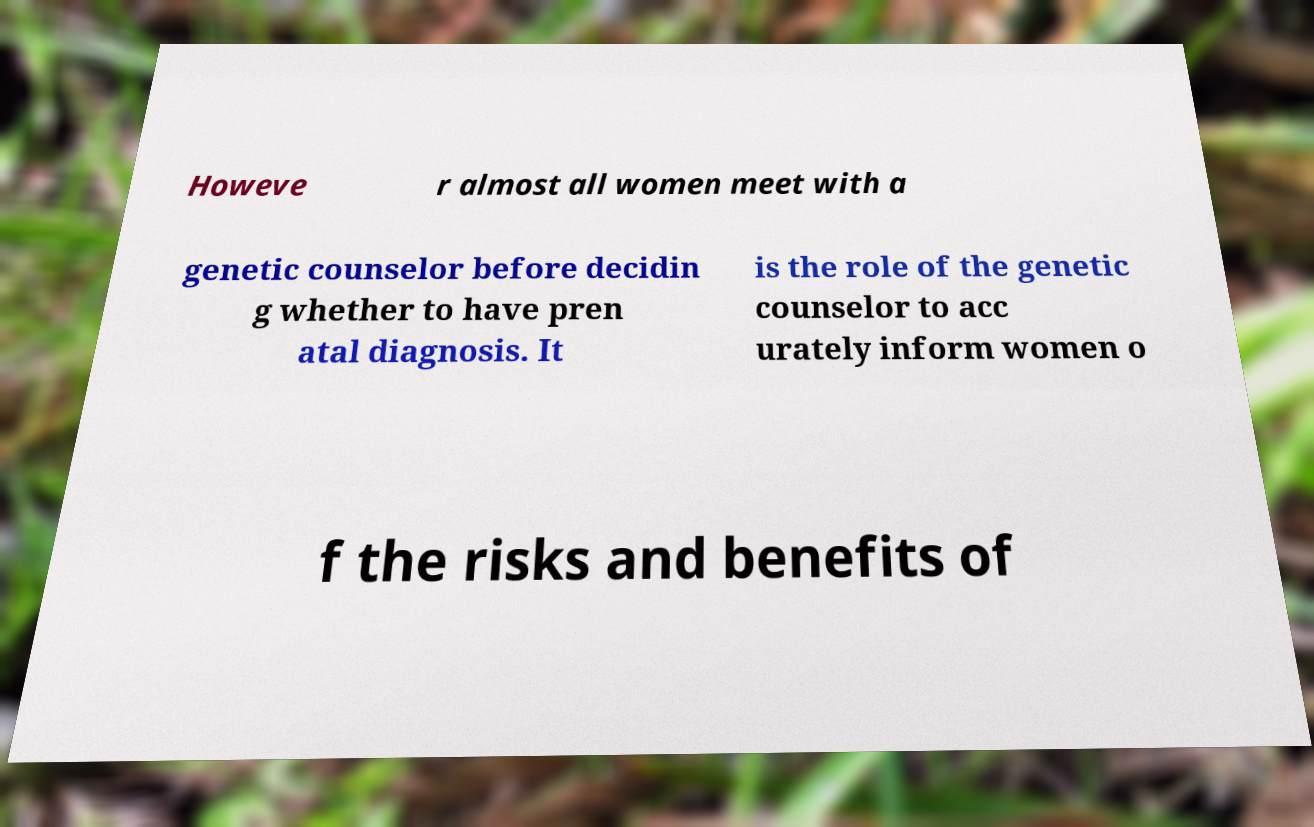Could you assist in decoding the text presented in this image and type it out clearly? Howeve r almost all women meet with a genetic counselor before decidin g whether to have pren atal diagnosis. It is the role of the genetic counselor to acc urately inform women o f the risks and benefits of 